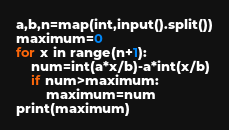<code> <loc_0><loc_0><loc_500><loc_500><_Python_>a,b,n=map(int,input().split())
maximum=0
for x in range(n+1):
    num=int(a*x/b)-a*int(x/b)
    if num>maximum:
        maximum=num
print(maximum)</code> 